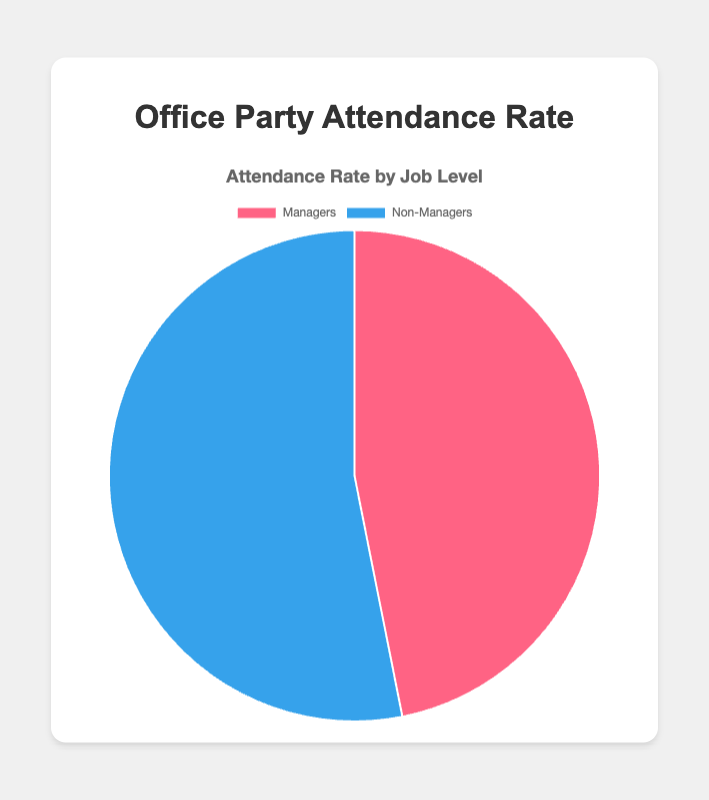Which job level has a higher attendance rate? By looking at the two segments, the attendance rate for Non-Managers is 85% compared to 75% for Managers. Therefore, Non-Managers have a higher attendance rate.
Answer: Non-Managers What is the difference in attendance rates between Managers and Non-Managers? The attendance rate for Non-Managers is 85%, and for Managers, it is 75%. The difference between these rates is 85% - 75%.
Answer: 10% How much higher is the attendance rate for Non-Managers compared to Managers in percentage points? The attendance rate for Non-Managers is 85%, and for Managers it is 75%. The difference in their attendance rates is 85% - 75%.
Answer: 10% What visual color represents the Managers' attendance rate? The color representing the Managers' attendance rate in the pie chart is pink/red.
Answer: Pink/Red If you average the attendance rates of Managers and Non-Managers, what would it be? The attendance rates are 75% for Managers and 85% for Non-Managers. The average is calculated as (75 + 85) / 2.
Answer: 80% What percentage of the total does the attendance rate for Managers represent? The attendance rate of Managers is 75%. Since percentages in a pie chart represent parts of a whole, Managers' segment is 75% of the total attendance shown in the chart.
Answer: 75% Based on the chart, which group is more likely to attend the office party? By comparing the two groups, the chart shows that Non-Managers have a higher attendance rate (85%) compared to Managers (75%), making Non-Managers more likely to attend the office party.
Answer: Non-Managers What is the total attendance rate if you combine both Managers and Non-Managers? In a pie chart, each segment represents a part of the total. Since we have attendance rates for both groups total 160% (75% + 85%). For average attendance rate, we consider their sum.
Answer: 160% 